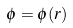<formula> <loc_0><loc_0><loc_500><loc_500>\phi = \phi ( r )</formula> 